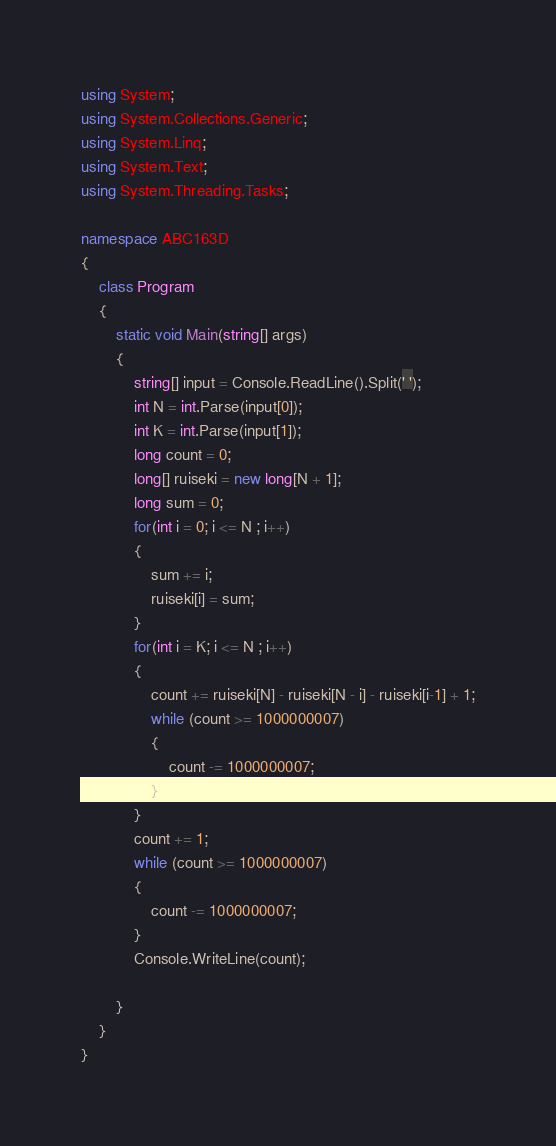Convert code to text. <code><loc_0><loc_0><loc_500><loc_500><_C#_>using System;
using System.Collections.Generic;
using System.Linq;
using System.Text;
using System.Threading.Tasks;

namespace ABC163D
{
    class Program
    {
        static void Main(string[] args)
        {
            string[] input = Console.ReadLine().Split(' ');
            int N = int.Parse(input[0]);
            int K = int.Parse(input[1]);
            long count = 0;
            long[] ruiseki = new long[N + 1];
            long sum = 0;
            for(int i = 0; i <= N ; i++)
            {
                sum += i;
                ruiseki[i] = sum;
            }
            for(int i = K; i <= N ; i++)
            {
                count += ruiseki[N] - ruiseki[N - i] - ruiseki[i-1] + 1;
                while (count >= 1000000007)
                {
                    count -= 1000000007;
                }
            }
            count += 1;
            while (count >= 1000000007)
            {
                count -= 1000000007;
            }
            Console.WriteLine(count);

        }
    }
}
</code> 